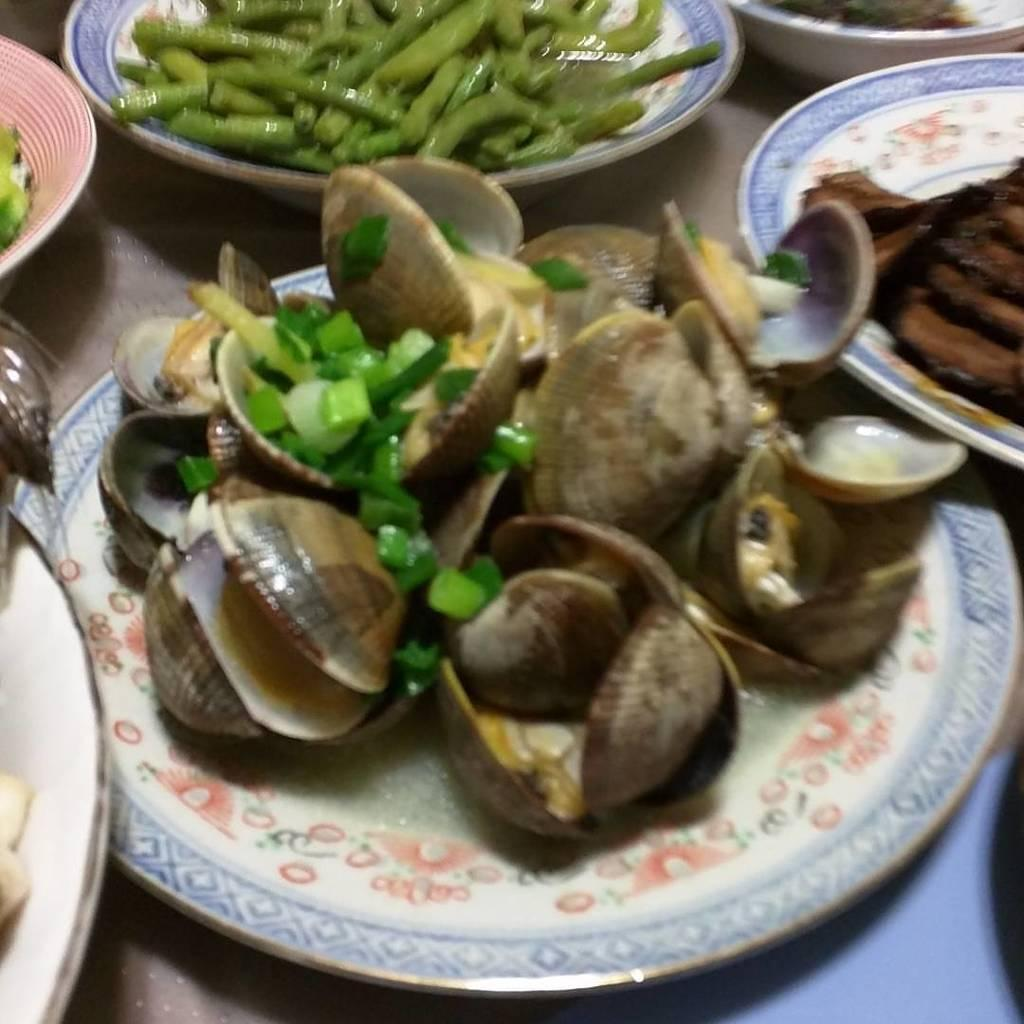What type of furniture is present in the image? There is a table in the image. What types of food items can be seen on the table? There are seafood, vegetable, and meat items on the table. How are the food items arranged on the table? The items are on plates. How many clocks can be seen hanging on the wall in the image? There are no clocks visible in the image. Is there a box containing seafood items on the table in the image? There is no box present in the image; the seafood items are on plates. 